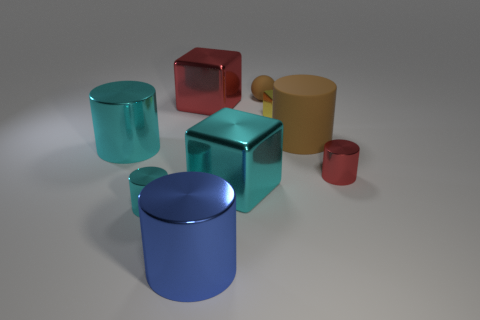How many cyan objects are either big metal things or matte spheres?
Ensure brevity in your answer.  2. Is the number of large metallic cylinders greater than the number of metal cylinders?
Keep it short and to the point. No. There is a rubber cylinder that is the same size as the red block; what color is it?
Offer a terse response. Brown. How many cylinders are tiny yellow shiny objects or big red metallic objects?
Offer a terse response. 0. There is a large rubber thing; is it the same shape as the cyan thing that is to the left of the small cyan shiny cylinder?
Your response must be concise. Yes. What number of brown cylinders are the same size as the blue object?
Your response must be concise. 1. Is the shape of the metal object right of the small yellow thing the same as the big cyan metallic object that is left of the big red cube?
Your answer should be very brief. Yes. The matte object that is the same color as the sphere is what shape?
Offer a very short reply. Cylinder. What color is the rubber object that is in front of the big shiny block that is on the left side of the blue metallic thing?
Make the answer very short. Brown. The tiny metal thing that is the same shape as the large red object is what color?
Your answer should be compact. Yellow. 